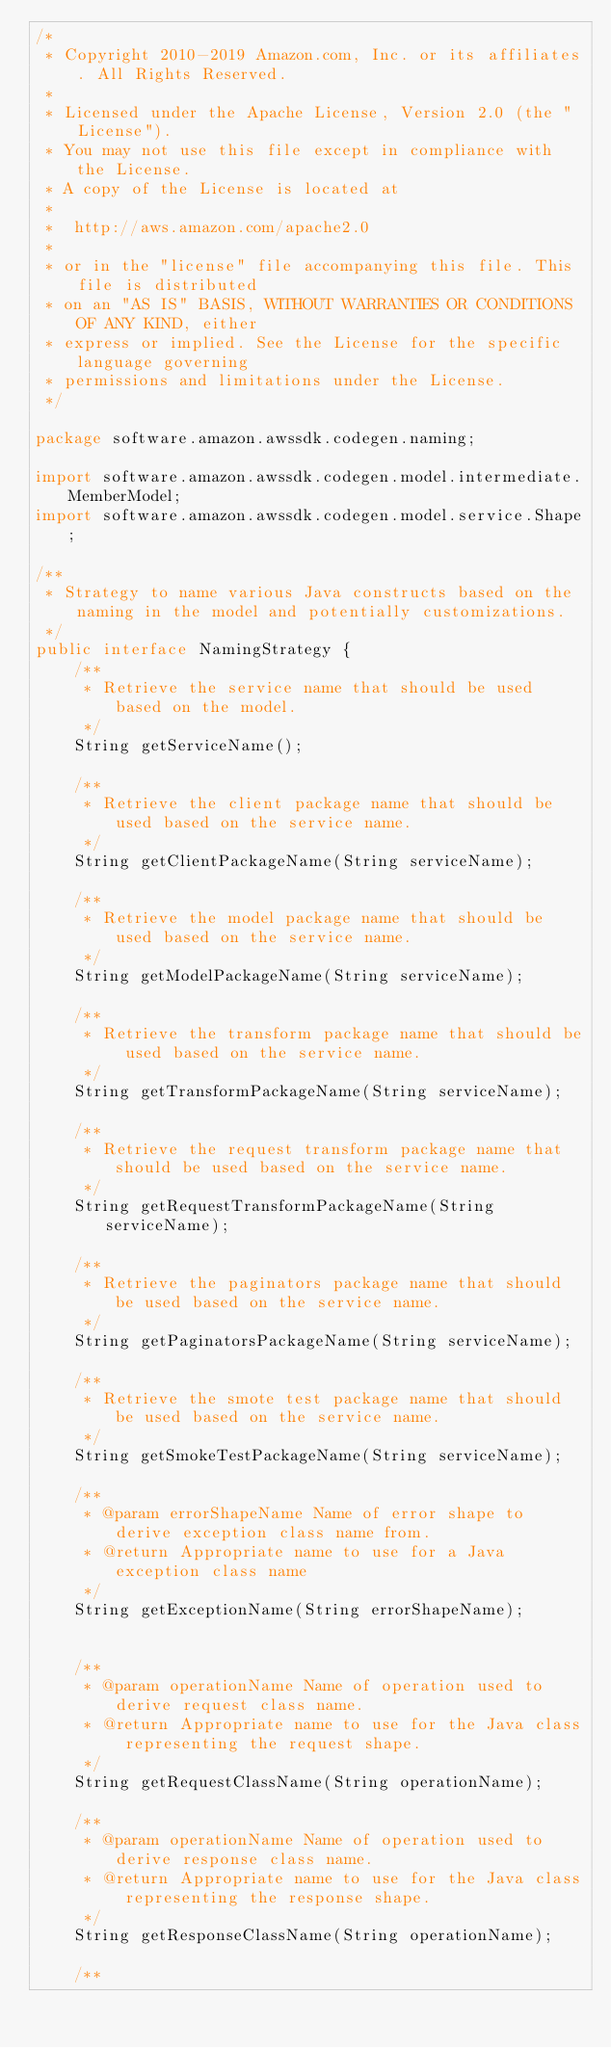<code> <loc_0><loc_0><loc_500><loc_500><_Java_>/*
 * Copyright 2010-2019 Amazon.com, Inc. or its affiliates. All Rights Reserved.
 *
 * Licensed under the Apache License, Version 2.0 (the "License").
 * You may not use this file except in compliance with the License.
 * A copy of the License is located at
 *
 *  http://aws.amazon.com/apache2.0
 *
 * or in the "license" file accompanying this file. This file is distributed
 * on an "AS IS" BASIS, WITHOUT WARRANTIES OR CONDITIONS OF ANY KIND, either
 * express or implied. See the License for the specific language governing
 * permissions and limitations under the License.
 */

package software.amazon.awssdk.codegen.naming;

import software.amazon.awssdk.codegen.model.intermediate.MemberModel;
import software.amazon.awssdk.codegen.model.service.Shape;

/**
 * Strategy to name various Java constructs based on the naming in the model and potentially customizations.
 */
public interface NamingStrategy {
    /**
     * Retrieve the service name that should be used based on the model.
     */
    String getServiceName();

    /**
     * Retrieve the client package name that should be used based on the service name.
     */
    String getClientPackageName(String serviceName);

    /**
     * Retrieve the model package name that should be used based on the service name.
     */
    String getModelPackageName(String serviceName);

    /**
     * Retrieve the transform package name that should be used based on the service name.
     */
    String getTransformPackageName(String serviceName);

    /**
     * Retrieve the request transform package name that should be used based on the service name.
     */
    String getRequestTransformPackageName(String serviceName);

    /**
     * Retrieve the paginators package name that should be used based on the service name.
     */
    String getPaginatorsPackageName(String serviceName);

    /**
     * Retrieve the smote test package name that should be used based on the service name.
     */
    String getSmokeTestPackageName(String serviceName);

    /**
     * @param errorShapeName Name of error shape to derive exception class name from.
     * @return Appropriate name to use for a Java exception class name
     */
    String getExceptionName(String errorShapeName);


    /**
     * @param operationName Name of operation used to derive request class name.
     * @return Appropriate name to use for the Java class representing the request shape.
     */
    String getRequestClassName(String operationName);

    /**
     * @param operationName Name of operation used to derive response class name.
     * @return Appropriate name to use for the Java class representing the response shape.
     */
    String getResponseClassName(String operationName);

    /**</code> 